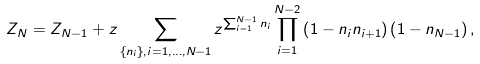<formula> <loc_0><loc_0><loc_500><loc_500>Z _ { N } = Z _ { N - 1 } + z \sum _ { \{ n _ { i } \} , i = 1 , \dots , N - 1 } z ^ { \sum _ { i = 1 } ^ { N - 1 } n _ { i } } \prod _ { i = 1 } ^ { N - 2 } \left ( 1 - n _ { i } n _ { i + 1 } \right ) \left ( 1 - n _ { N - 1 } \right ) ,</formula> 